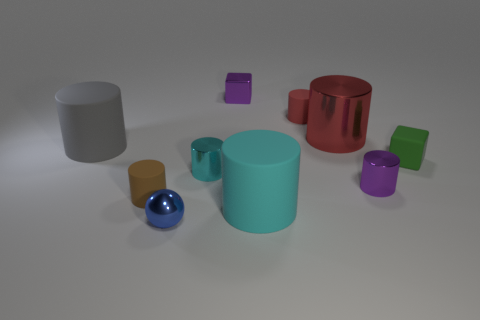Are there any reflections visible on the surfaces of the objects? Yes, reflections can be noticed on the objects, particularly on the glossy surfaces. The shiny blue sphere and the red cylinder reflect the environment and exhibit a greater degree of reflectivity compared to the others.  What might those reflections suggest about the environment around the objects? The reflections suggest that the objects are situated in a room with a light source above, as indicated by the bright spots on the glossy surfaces. It's a controlled, static setting typical for a 3D rendering or a studio-like environment. 